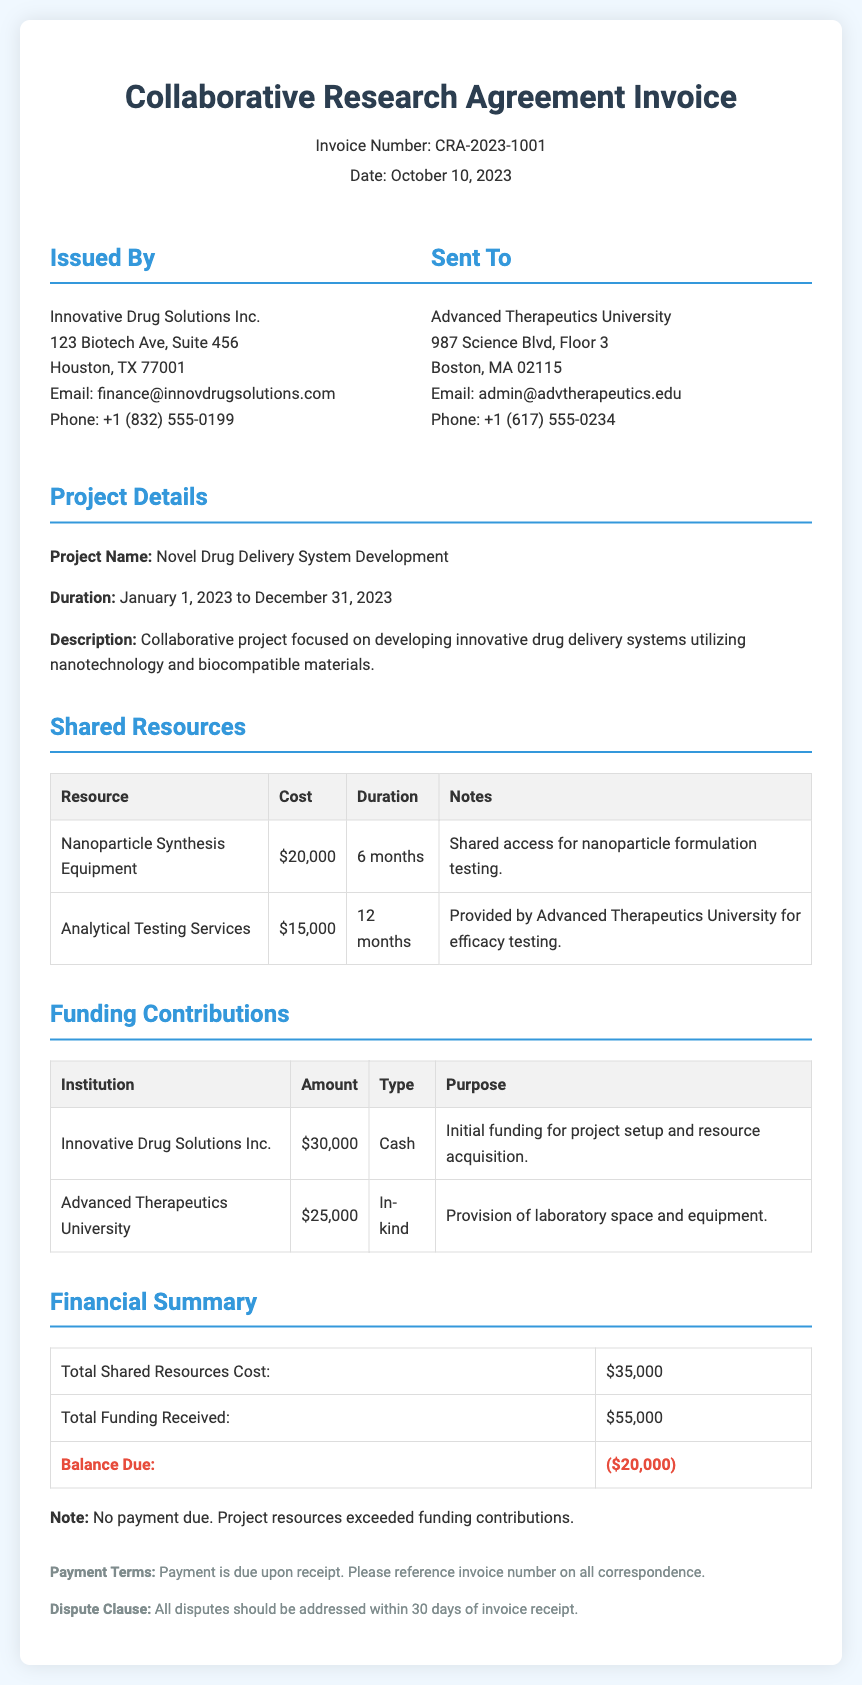what is the invoice number? The invoice number is clearly stated in the document header as CRA-2023-1001.
Answer: CRA-2023-1001 what is the total shared resources cost? The total shared resources cost is listed in the financial summary section as $35,000.
Answer: $35,000 what is the duration of the project? The project duration is specified as January 1, 2023 to December 31, 2023.
Answer: January 1, 2023 to December 31, 2023 who provided the analytical testing services? The document states that the analytical testing services are provided by Advanced Therapeutics University.
Answer: Advanced Therapeutics University what is the balance due? In the financial summary, the balance due is indicated as ($20,000).
Answer: ($20,000) what type of agreement is this document related to? The document is related to a Collaborative Research Agreement as mentioned in the title.
Answer: Collaborative Research Agreement how much funding did Innovative Drug Solutions Inc. contribute? The amount contributed by Innovative Drug Solutions Inc. is stated as $30,000 in the funding contributions section.
Answer: $30,000 what is stated regarding payment terms? The payment terms section indicates that payment is due upon receipt.
Answer: Payment is due upon receipt how long is the nanoparticle synthesis equipment shared for? The duration for which the nanoparticle synthesis equipment is shared is mentioned as 6 months.
Answer: 6 months 